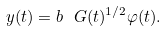<formula> <loc_0><loc_0><loc_500><loc_500>y ( t ) = b _ { \ } G ( t ) ^ { 1 / 2 } \varphi ( t ) .</formula> 